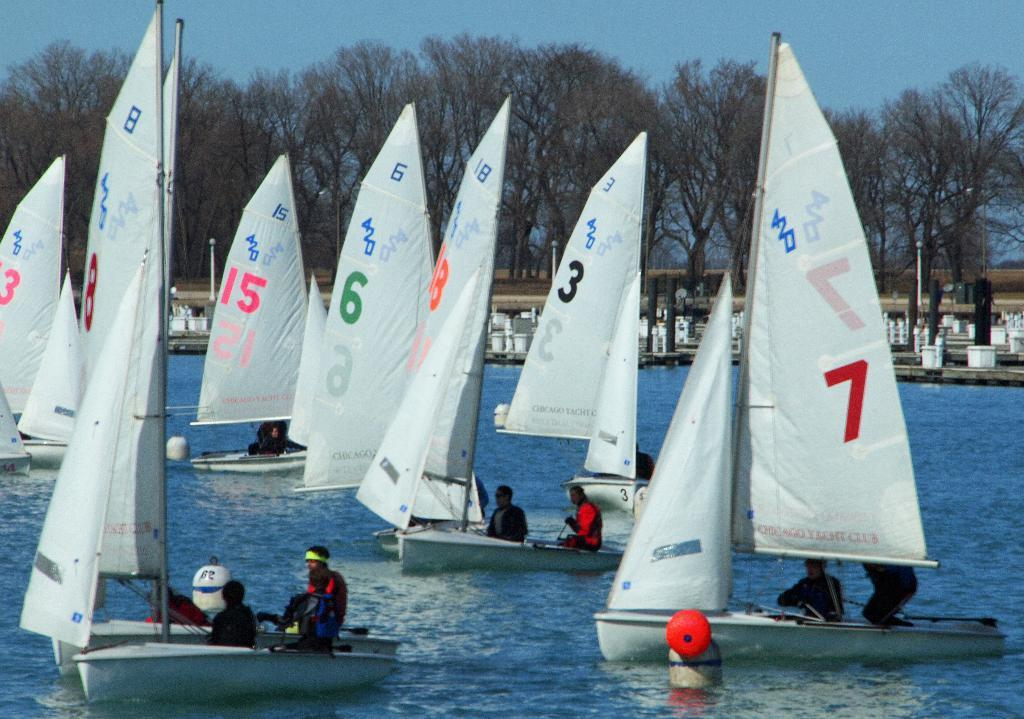What is located in the center of the image? There are boats in the water in the center of the image. What can be seen in the background of the image? There are trees in the background of the image. What is visible at the top of the image? The sky is visible at the top of the image. What type of sign can be seen in the water near the boats? There is no sign present in the water near the boats; only the boats and water are visible. What kind of furniture is located on the boats in the image? There is no furniture visible on the boats in the image. 